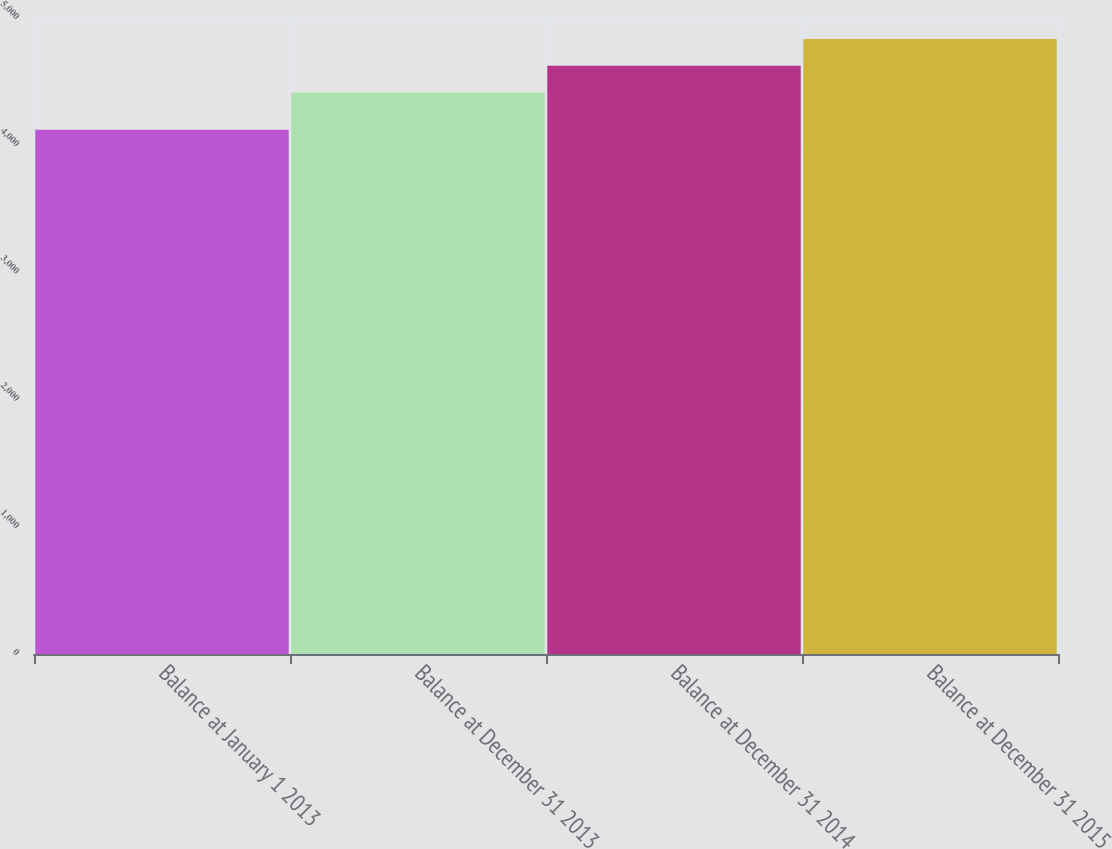Convert chart. <chart><loc_0><loc_0><loc_500><loc_500><bar_chart><fcel>Balance at January 1 2013<fcel>Balance at December 31 2013<fcel>Balance at December 31 2014<fcel>Balance at December 31 2015<nl><fcel>4122<fcel>4415<fcel>4625<fcel>4834<nl></chart> 